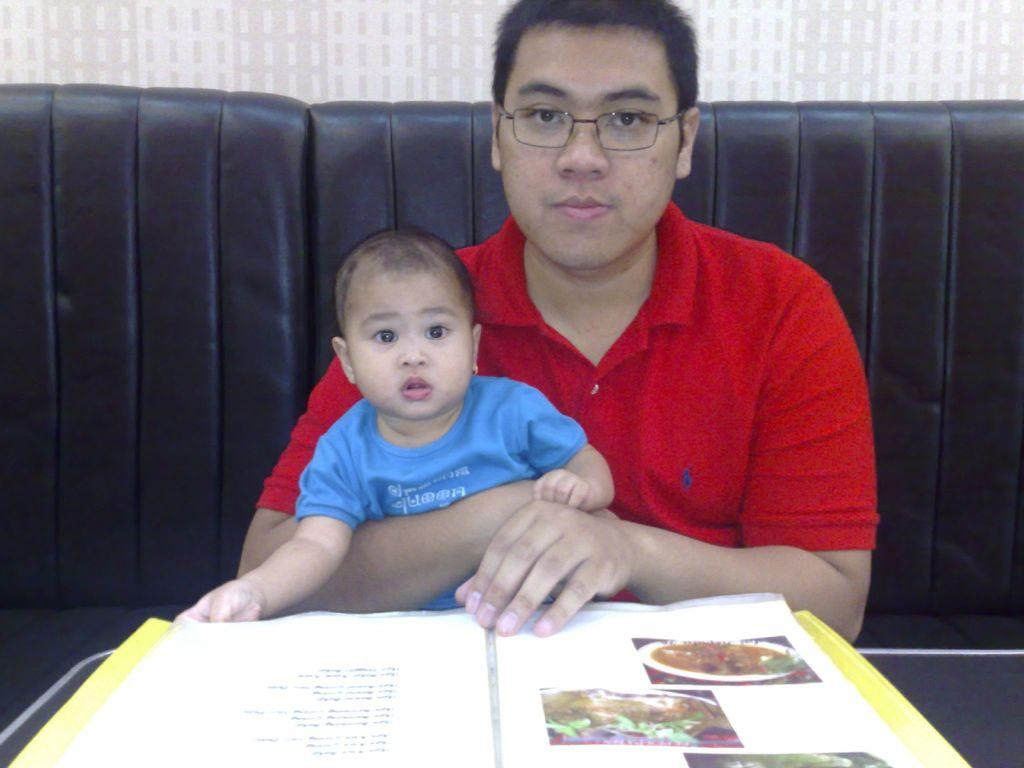Who is present in the image with the man? There is a baby in the image with the man. Where are the man and the baby sitting? They are sitting on a sofa. What can be seen on the table in the image? There is a menu on the table. What is visible in the background of the image? There is a wall in the background of the image. What type of sponge is the baby using to clean the wall in the image? There is no sponge or wall cleaning activity depicted in the image. 